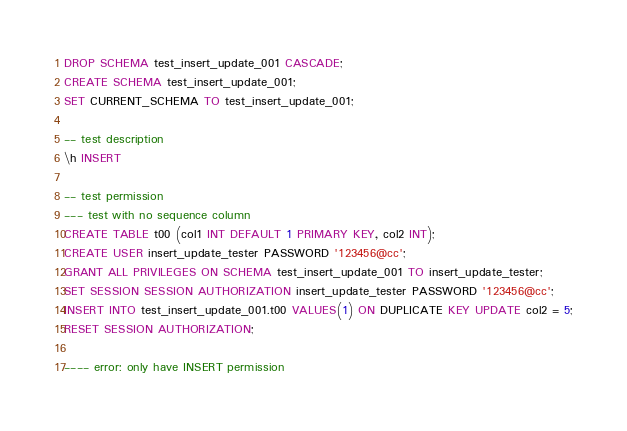Convert code to text. <code><loc_0><loc_0><loc_500><loc_500><_SQL_>
DROP SCHEMA test_insert_update_001 CASCADE;
CREATE SCHEMA test_insert_update_001;
SET CURRENT_SCHEMA TO test_insert_update_001;

-- test description
\h INSERT

-- test permission
--- test with no sequence column
CREATE TABLE t00 (col1 INT DEFAULT 1 PRIMARY KEY, col2 INT);
CREATE USER insert_update_tester PASSWORD '123456@cc';
GRANT ALL PRIVILEGES ON SCHEMA test_insert_update_001 TO insert_update_tester;
SET SESSION SESSION AUTHORIZATION insert_update_tester PASSWORD '123456@cc';
INSERT INTO test_insert_update_001.t00 VALUES(1) ON DUPLICATE KEY UPDATE col2 = 5;
RESET SESSION AUTHORIZATION;

---- error: only have INSERT permission</code> 